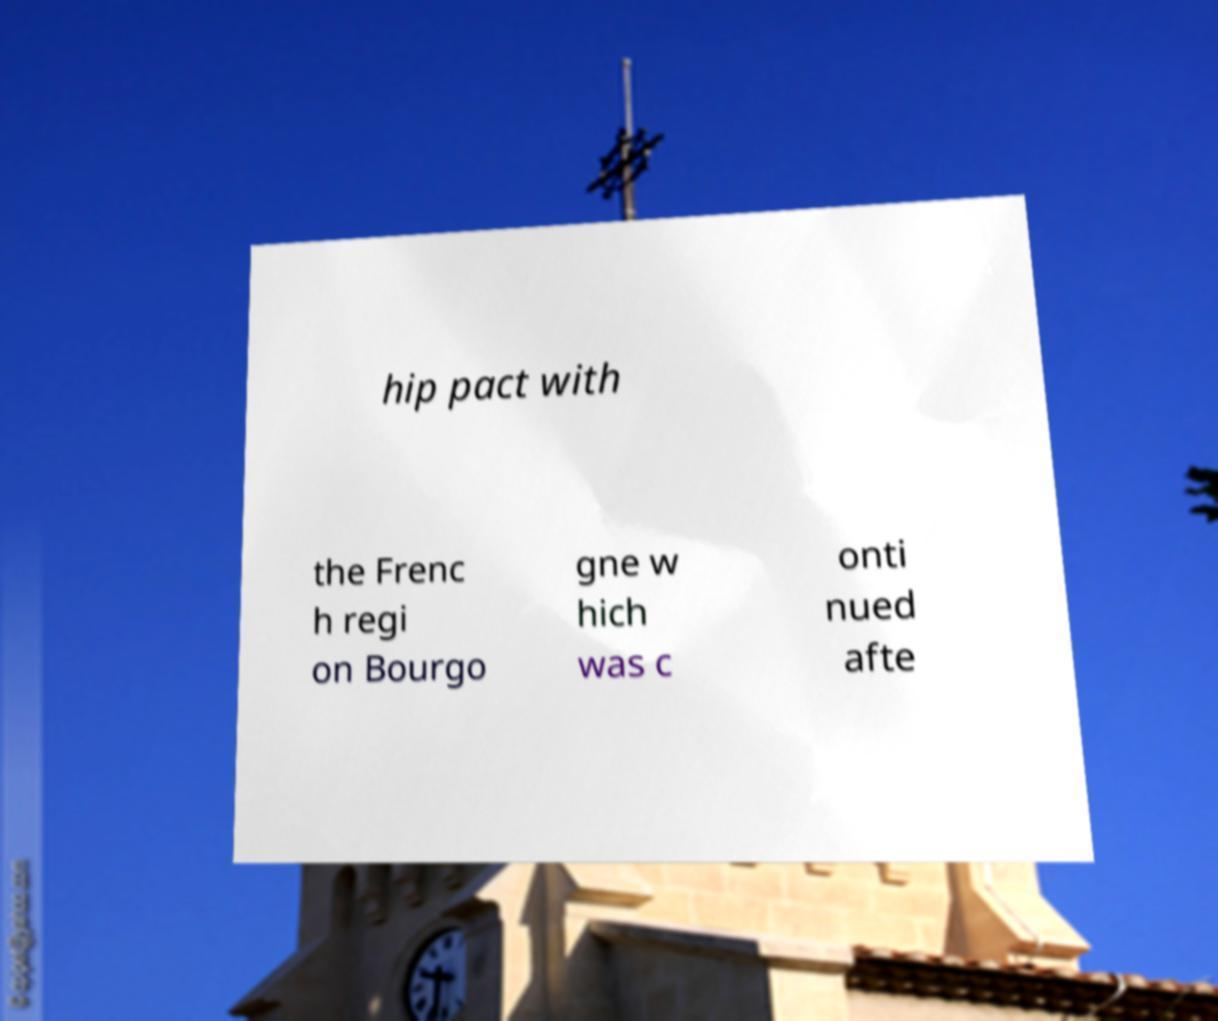What messages or text are displayed in this image? I need them in a readable, typed format. hip pact with the Frenc h regi on Bourgo gne w hich was c onti nued afte 